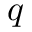<formula> <loc_0><loc_0><loc_500><loc_500>q</formula> 